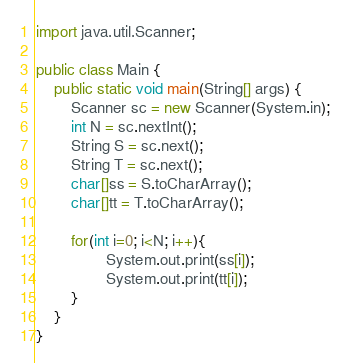<code> <loc_0><loc_0><loc_500><loc_500><_Java_>import java.util.Scanner;
 
public class Main {
	public static void main(String[] args) {
		Scanner sc = new Scanner(System.in);
        int N = sc.nextInt();
        String S = sc.next();
        String T = sc.next();
        char[]ss = S.toCharArray();
        char[]tt = T.toCharArray();       

        for(int i=0; i<N; i++){
                System.out.print(ss[i]);
                System.out.print(tt[i]);
        }
	}
}
</code> 